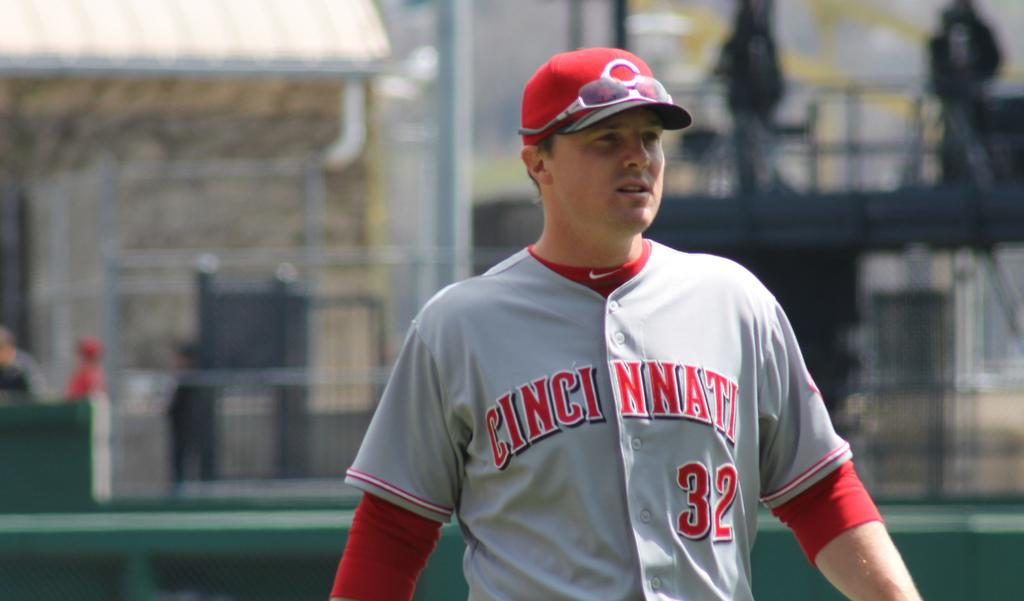<image>
Render a clear and concise summary of the photo. A baseball player wearing a top with the number 32 on it and Cincinnati watches as the game plays out. 